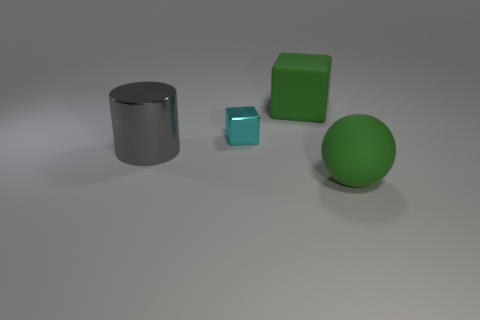Add 3 small cyan metallic cubes. How many objects exist? 7 Subtract all cylinders. How many objects are left? 3 Subtract 1 blocks. How many blocks are left? 1 Subtract all red cylinders. Subtract all gray spheres. How many cylinders are left? 1 Subtract all balls. Subtract all big metal cylinders. How many objects are left? 2 Add 2 tiny cyan blocks. How many tiny cyan blocks are left? 3 Add 2 green balls. How many green balls exist? 3 Subtract 0 cyan spheres. How many objects are left? 4 